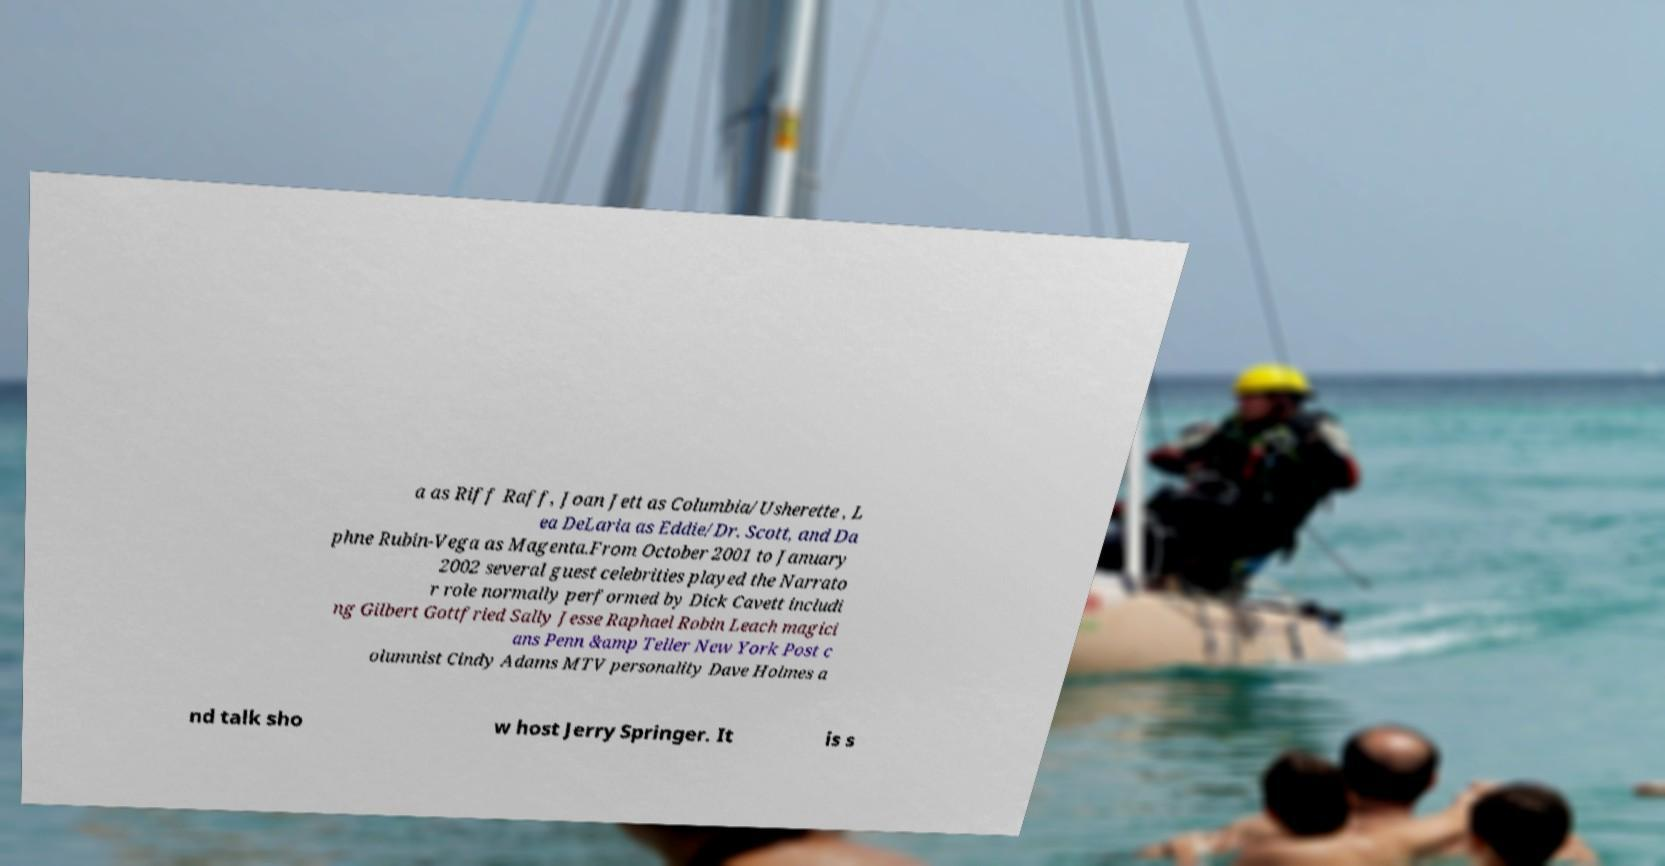Please read and relay the text visible in this image. What does it say? a as Riff Raff, Joan Jett as Columbia/Usherette , L ea DeLaria as Eddie/Dr. Scott, and Da phne Rubin-Vega as Magenta.From October 2001 to January 2002 several guest celebrities played the Narrato r role normally performed by Dick Cavett includi ng Gilbert Gottfried Sally Jesse Raphael Robin Leach magici ans Penn &amp Teller New York Post c olumnist Cindy Adams MTV personality Dave Holmes a nd talk sho w host Jerry Springer. It is s 